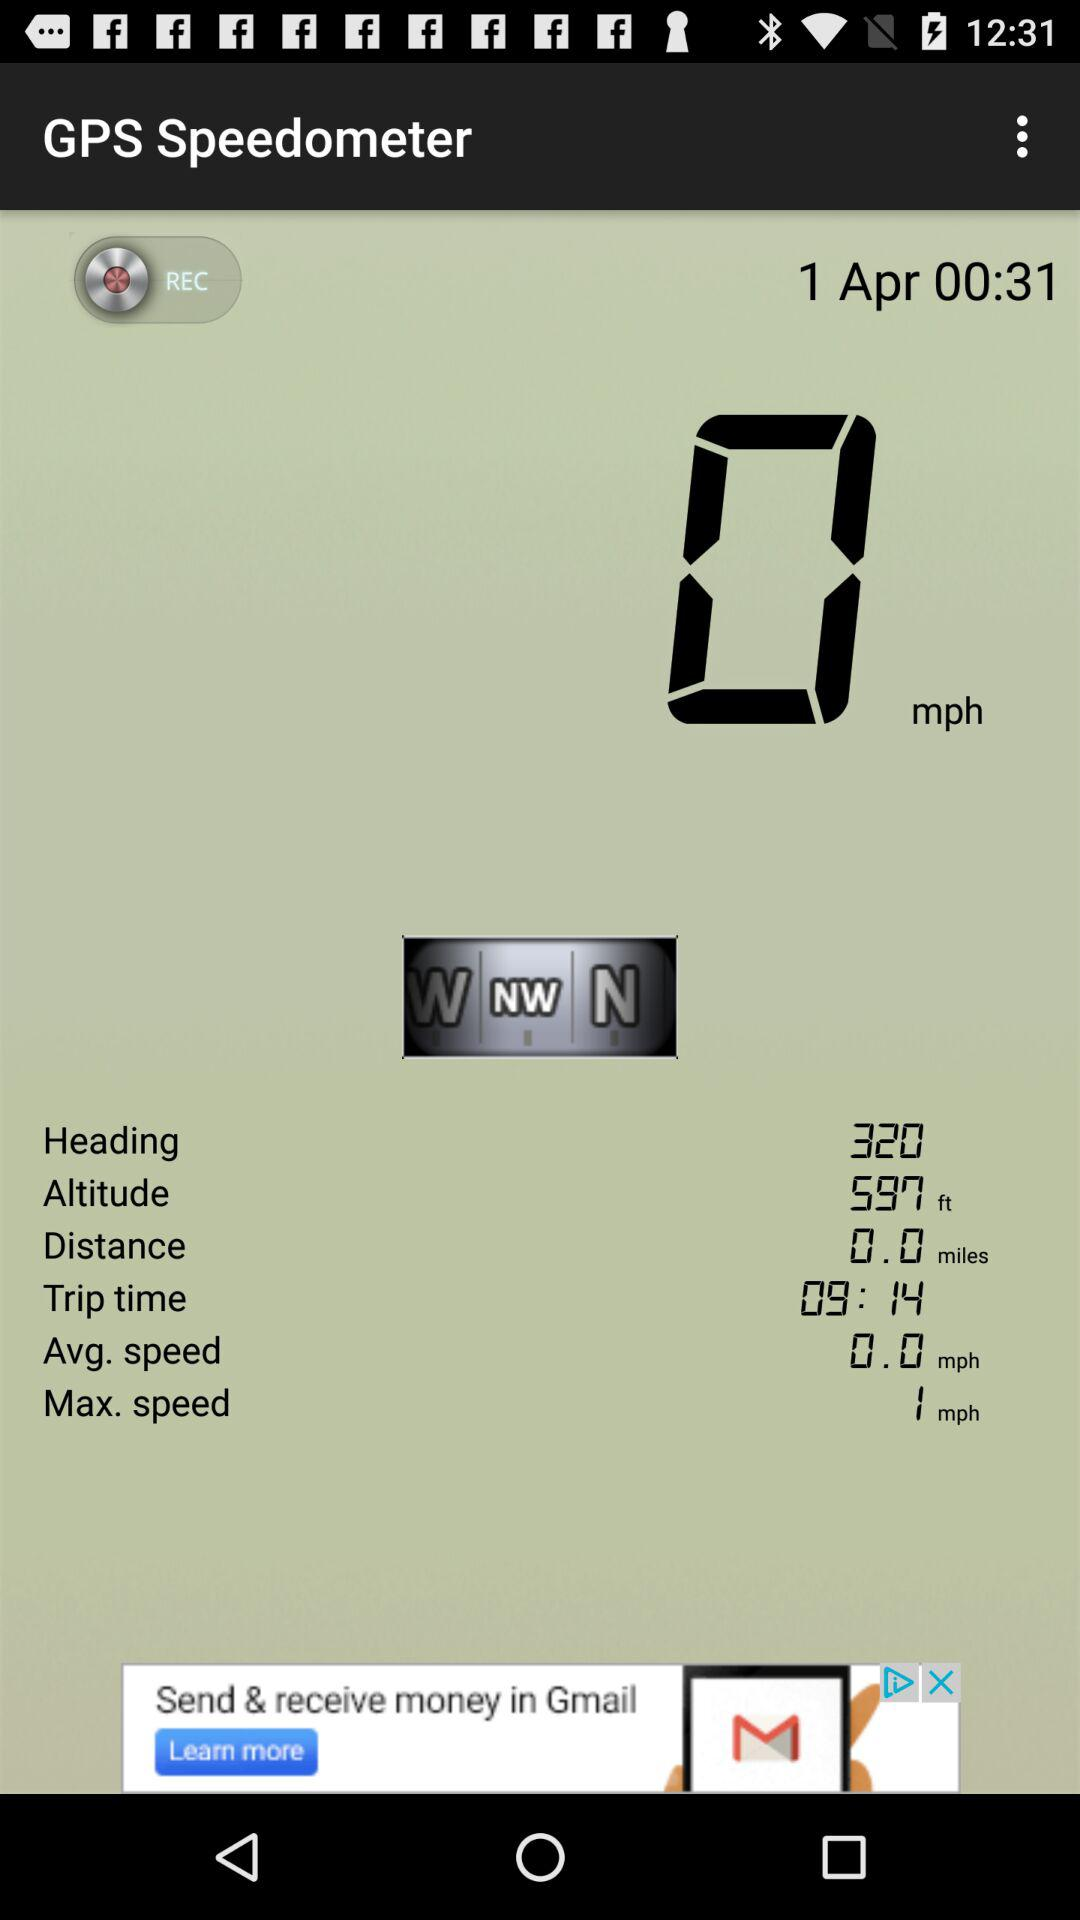What is the maximum speed? The maximum speed is 1 mph. 